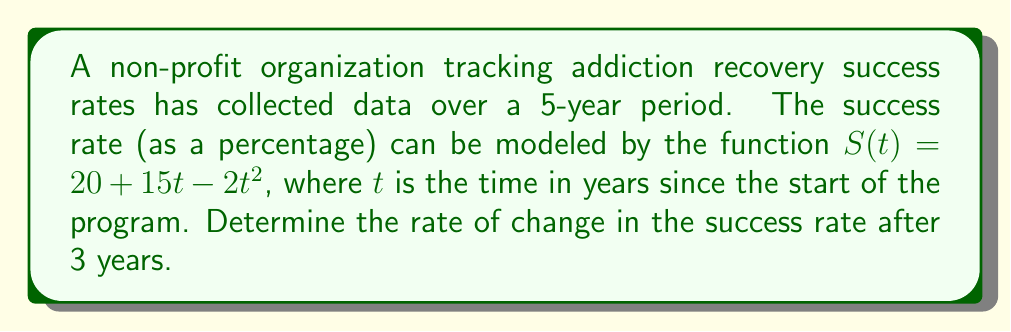Can you solve this math problem? To solve this problem, we need to find the derivative of the given function and then evaluate it at $t = 3$. Here's the step-by-step process:

1. The given function is $S(t) = 20 + 15t - 2t^2$

2. To find the rate of change, we need to calculate the first derivative of $S(t)$:
   
   $$\frac{d}{dt}S(t) = \frac{d}{dt}(20) + \frac{d}{dt}(15t) - \frac{d}{dt}(2t^2)$$

3. Applying the rules of differentiation:
   - The derivative of a constant (20) is 0
   - The derivative of $15t$ is 15
   - The derivative of $2t^2$ is $2 \cdot 2t = 4t$ (using the power rule)

4. Therefore, the derivative is:
   
   $$S'(t) = 0 + 15 - 4t = 15 - 4t$$

5. To find the rate of change after 3 years, we evaluate $S'(t)$ at $t = 3$:
   
   $$S'(3) = 15 - 4(3) = 15 - 12 = 3$$

The rate of change is 3 percentage points per year after 3 years.
Answer: $3$ percentage points per year 